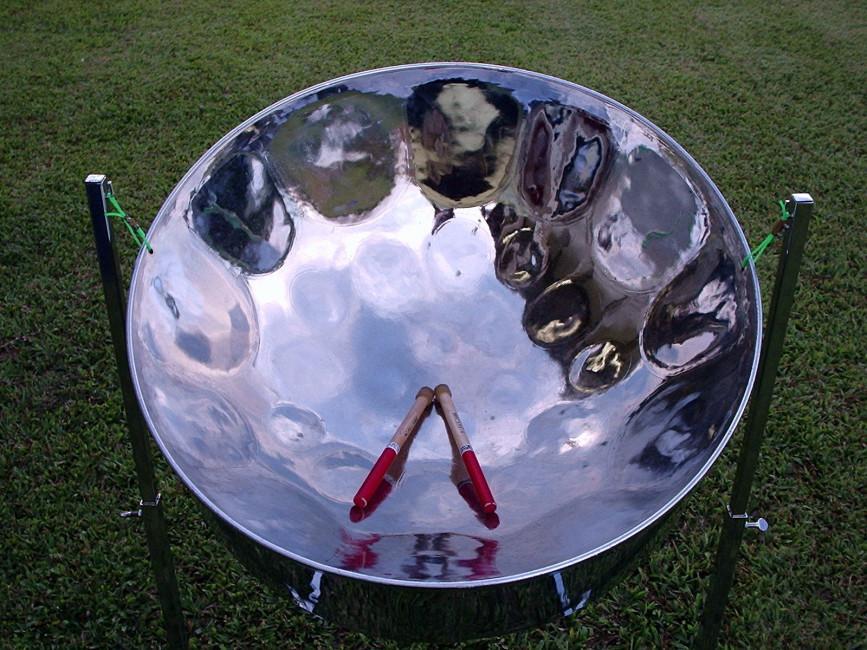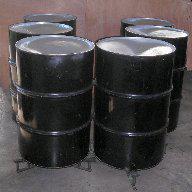The first image is the image on the left, the second image is the image on the right. For the images shown, is this caption "There is a total of three drums." true? Answer yes or no. No. The first image is the image on the left, the second image is the image on the right. Examine the images to the left and right. Is the description "Two hands belonging to someone wearing a hawaiaan shirt are holding drumsticks over the concave bowl of a steel drum in one image, and the other image shows the bowl of at least one drum with no drumsticks in it." accurate? Answer yes or no. No. 